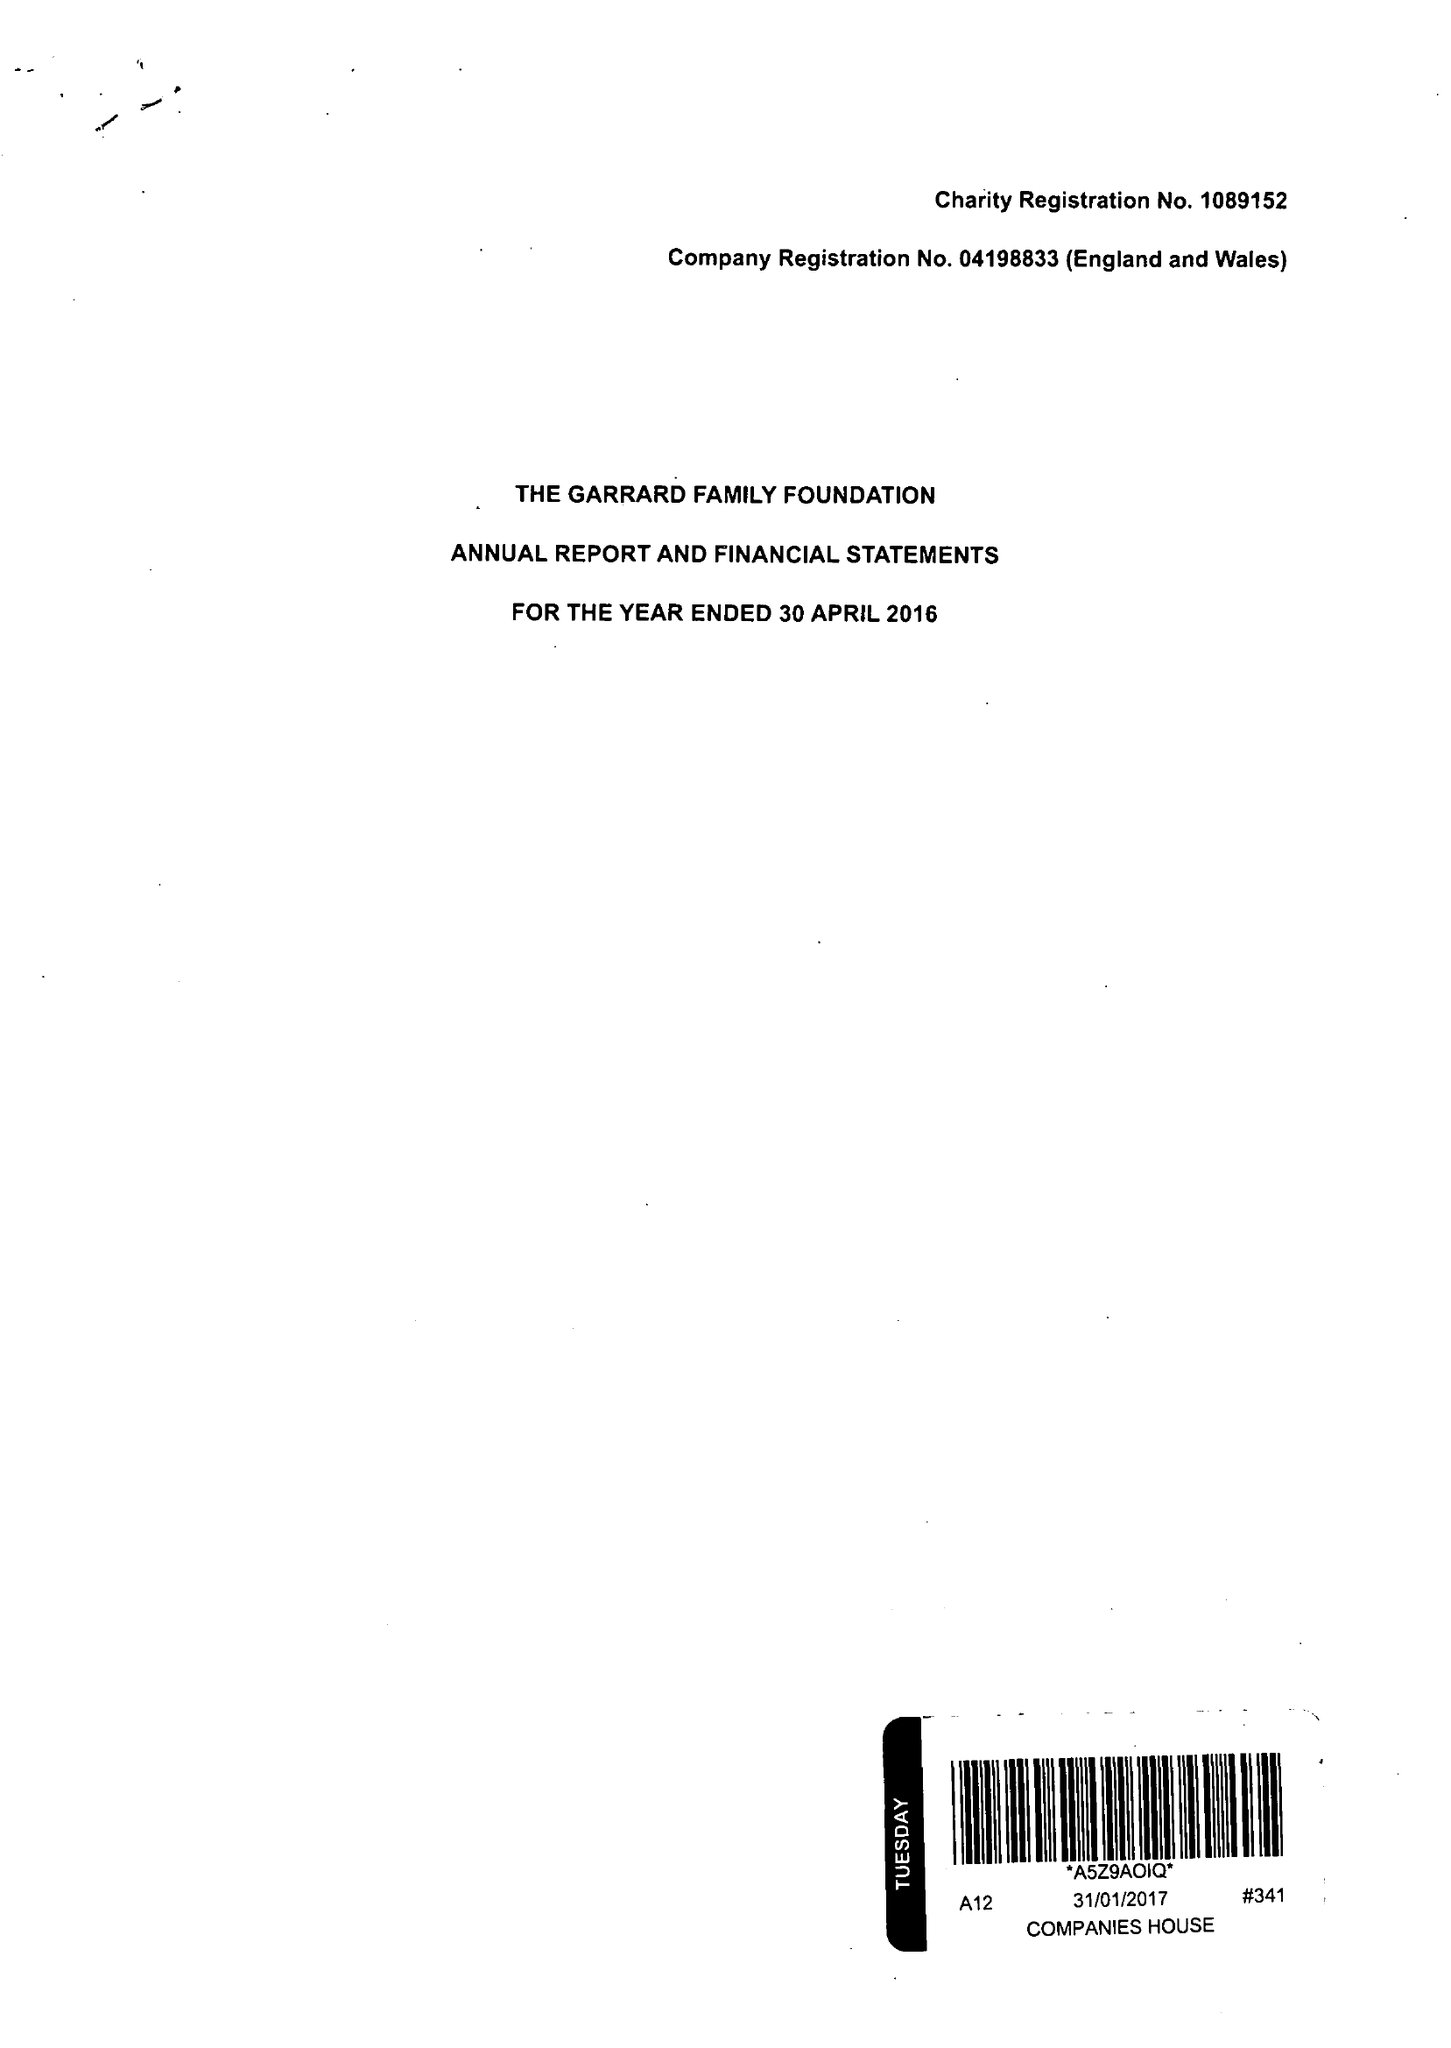What is the value for the charity_name?
Answer the question using a single word or phrase. The Garrard Family Foundation 